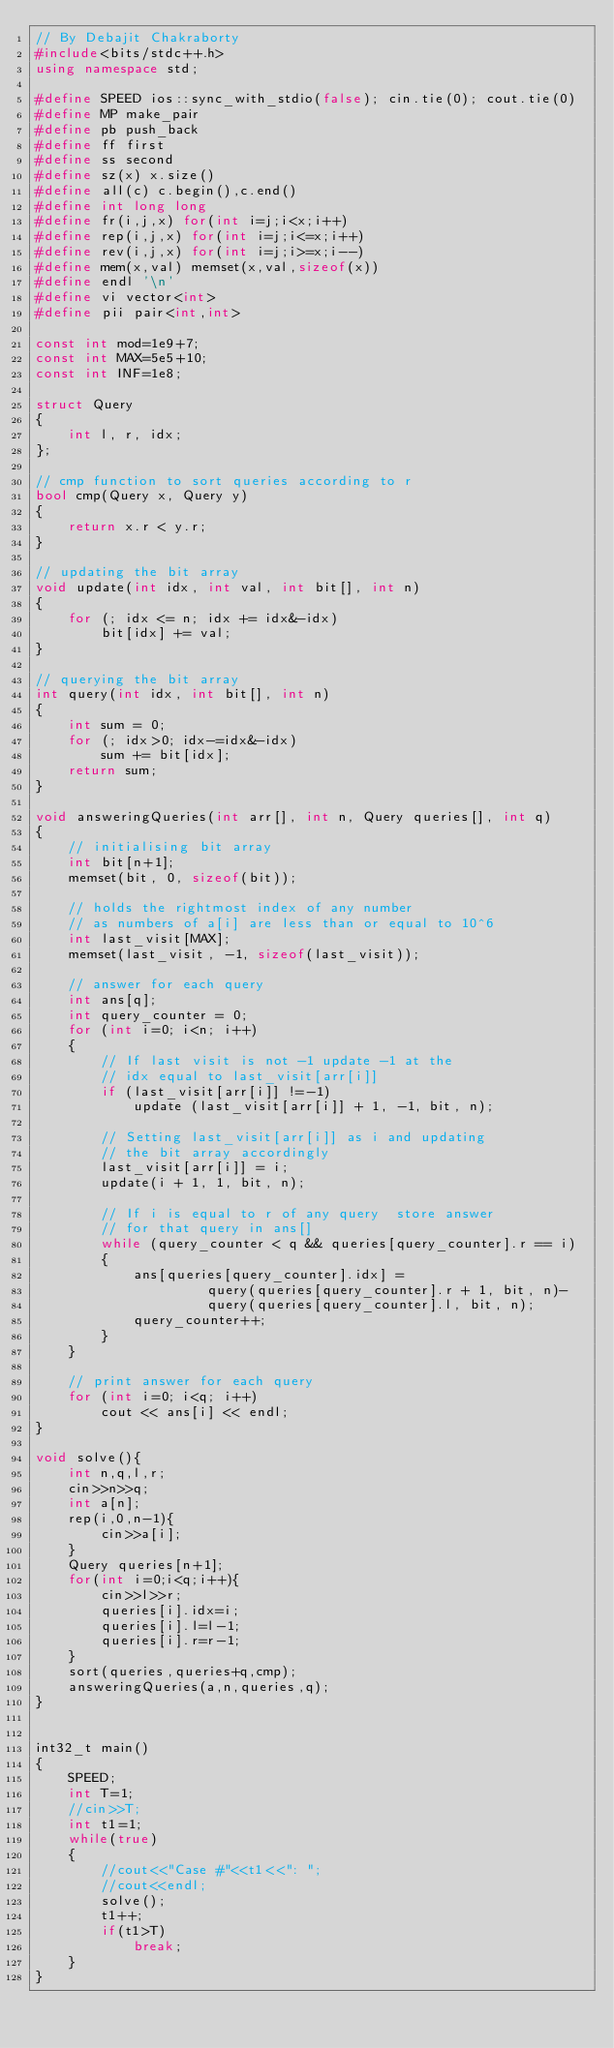<code> <loc_0><loc_0><loc_500><loc_500><_C++_>// By Debajit Chakraborty
#include<bits/stdc++.h>
using namespace std;
 
#define SPEED ios::sync_with_stdio(false); cin.tie(0); cout.tie(0)
#define MP make_pair
#define pb push_back
#define ff first
#define ss second
#define sz(x) x.size()
#define all(c) c.begin(),c.end()
#define int long long
#define fr(i,j,x) for(int i=j;i<x;i++)
#define rep(i,j,x) for(int i=j;i<=x;i++)
#define rev(i,j,x) for(int i=j;i>=x;i--)
#define mem(x,val) memset(x,val,sizeof(x))
#define endl '\n'
#define vi vector<int>
#define pii pair<int,int>
 
const int mod=1e9+7;
const int MAX=5e5+10;
const int INF=1e8;

struct Query 
{ 
    int l, r, idx; 
}; 
  
// cmp function to sort queries according to r 
bool cmp(Query x, Query y) 
{ 
    return x.r < y.r; 
} 
  
// updating the bit array 
void update(int idx, int val, int bit[], int n) 
{ 
    for (; idx <= n; idx += idx&-idx) 
        bit[idx] += val; 
} 
  
// querying the bit array 
int query(int idx, int bit[], int n) 
{ 
    int sum = 0; 
    for (; idx>0; idx-=idx&-idx) 
        sum += bit[idx]; 
    return sum; 
} 
  
void answeringQueries(int arr[], int n, Query queries[], int q) 
{ 
    // initialising bit array 
    int bit[n+1]; 
    memset(bit, 0, sizeof(bit)); 
  
    // holds the rightmost index of any number 
    // as numbers of a[i] are less than or equal to 10^6 
    int last_visit[MAX]; 
    memset(last_visit, -1, sizeof(last_visit)); 
  
    // answer for each query 
    int ans[q]; 
    int query_counter = 0; 
    for (int i=0; i<n; i++) 
    { 
        // If last visit is not -1 update -1 at the 
        // idx equal to last_visit[arr[i]] 
        if (last_visit[arr[i]] !=-1) 
            update (last_visit[arr[i]] + 1, -1, bit, n); 
  
        // Setting last_visit[arr[i]] as i and updating 
        // the bit array accordingly 
        last_visit[arr[i]] = i; 
        update(i + 1, 1, bit, n); 
  
        // If i is equal to r of any query  store answer 
        // for that query in ans[] 
        while (query_counter < q && queries[query_counter].r == i) 
        { 
            ans[queries[query_counter].idx] = 
                     query(queries[query_counter].r + 1, bit, n)- 
                     query(queries[query_counter].l, bit, n); 
            query_counter++; 
        } 
    } 
  
    // print answer for each query 
    for (int i=0; i<q; i++) 
        cout << ans[i] << endl; 
} 

void solve(){
    int n,q,l,r;
    cin>>n>>q;
    int a[n];
    rep(i,0,n-1){
        cin>>a[i];
    }
    Query queries[n+1];
    for(int i=0;i<q;i++){
        cin>>l>>r;
        queries[i].idx=i;
        queries[i].l=l-1;
        queries[i].r=r-1;
    }
    sort(queries,queries+q,cmp);
    answeringQueries(a,n,queries,q);
}


int32_t main()
{
    SPEED;
    int T=1;
    //cin>>T;
    int t1=1;
    while(true)
    {  
        //cout<<"Case #"<<t1<<": ";
        //cout<<endl;
        solve();
        t1++;
        if(t1>T)
            break;
    }
}   
</code> 